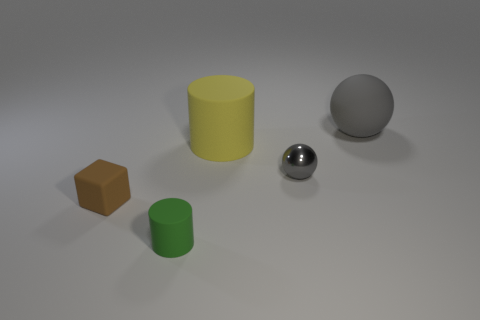Add 2 large gray spheres. How many objects exist? 7 Subtract all blocks. How many objects are left? 4 Add 5 matte blocks. How many matte blocks are left? 6 Add 2 red shiny cylinders. How many red shiny cylinders exist? 2 Subtract 1 brown cubes. How many objects are left? 4 Subtract all small gray metallic balls. Subtract all gray metal objects. How many objects are left? 3 